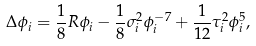<formula> <loc_0><loc_0><loc_500><loc_500>\Delta \phi _ { i } = \frac { 1 } { 8 } R \phi _ { i } - \frac { 1 } { 8 } \sigma _ { i } ^ { 2 } \phi _ { i } ^ { - 7 } + \frac { 1 } { 1 2 } \tau _ { i } ^ { 2 } \phi _ { i } ^ { 5 } ,</formula> 